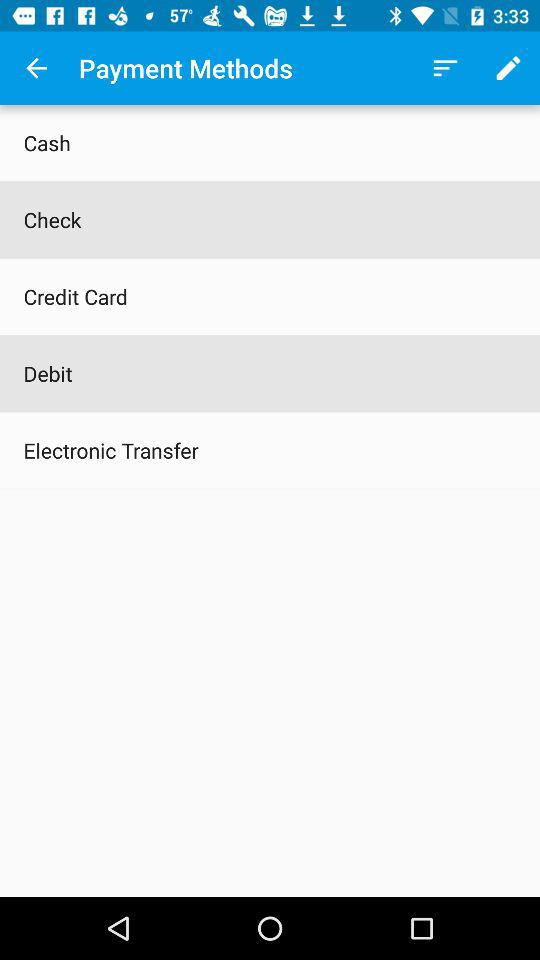What payment methods do we have? The payment methods that you have are "Cash", "Check", "Credit Card", "Debit" and "Electronic Transfer". 